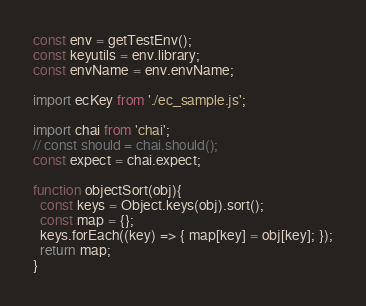Convert code to text. <code><loc_0><loc_0><loc_500><loc_500><_JavaScript_>const env = getTestEnv();
const keyutils = env.library;
const envName = env.envName;

import ecKey from './ec_sample.js';

import chai from 'chai';
// const should = chai.should();
const expect = chai.expect;

function objectSort(obj){
  const keys = Object.keys(obj).sort();
  const map = {};
  keys.forEach((key) => { map[key] = obj[key]; });
  return map;
}
</code> 